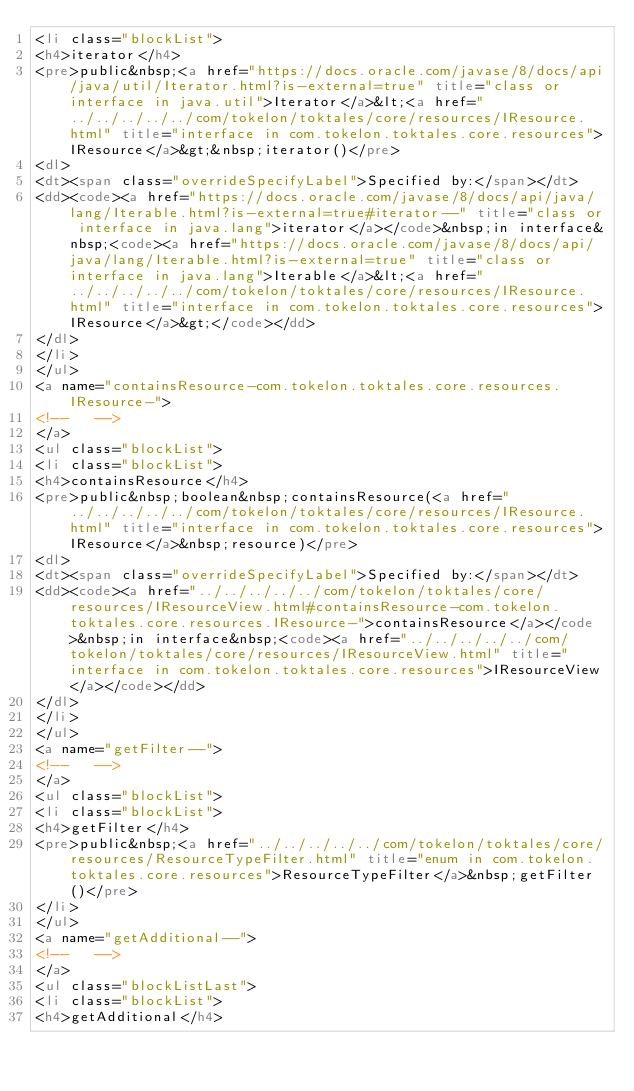<code> <loc_0><loc_0><loc_500><loc_500><_HTML_><li class="blockList">
<h4>iterator</h4>
<pre>public&nbsp;<a href="https://docs.oracle.com/javase/8/docs/api/java/util/Iterator.html?is-external=true" title="class or interface in java.util">Iterator</a>&lt;<a href="../../../../../com/tokelon/toktales/core/resources/IResource.html" title="interface in com.tokelon.toktales.core.resources">IResource</a>&gt;&nbsp;iterator()</pre>
<dl>
<dt><span class="overrideSpecifyLabel">Specified by:</span></dt>
<dd><code><a href="https://docs.oracle.com/javase/8/docs/api/java/lang/Iterable.html?is-external=true#iterator--" title="class or interface in java.lang">iterator</a></code>&nbsp;in interface&nbsp;<code><a href="https://docs.oracle.com/javase/8/docs/api/java/lang/Iterable.html?is-external=true" title="class or interface in java.lang">Iterable</a>&lt;<a href="../../../../../com/tokelon/toktales/core/resources/IResource.html" title="interface in com.tokelon.toktales.core.resources">IResource</a>&gt;</code></dd>
</dl>
</li>
</ul>
<a name="containsResource-com.tokelon.toktales.core.resources.IResource-">
<!--   -->
</a>
<ul class="blockList">
<li class="blockList">
<h4>containsResource</h4>
<pre>public&nbsp;boolean&nbsp;containsResource(<a href="../../../../../com/tokelon/toktales/core/resources/IResource.html" title="interface in com.tokelon.toktales.core.resources">IResource</a>&nbsp;resource)</pre>
<dl>
<dt><span class="overrideSpecifyLabel">Specified by:</span></dt>
<dd><code><a href="../../../../../com/tokelon/toktales/core/resources/IResourceView.html#containsResource-com.tokelon.toktales.core.resources.IResource-">containsResource</a></code>&nbsp;in interface&nbsp;<code><a href="../../../../../com/tokelon/toktales/core/resources/IResourceView.html" title="interface in com.tokelon.toktales.core.resources">IResourceView</a></code></dd>
</dl>
</li>
</ul>
<a name="getFilter--">
<!--   -->
</a>
<ul class="blockList">
<li class="blockList">
<h4>getFilter</h4>
<pre>public&nbsp;<a href="../../../../../com/tokelon/toktales/core/resources/ResourceTypeFilter.html" title="enum in com.tokelon.toktales.core.resources">ResourceTypeFilter</a>&nbsp;getFilter()</pre>
</li>
</ul>
<a name="getAdditional--">
<!--   -->
</a>
<ul class="blockListLast">
<li class="blockList">
<h4>getAdditional</h4></code> 